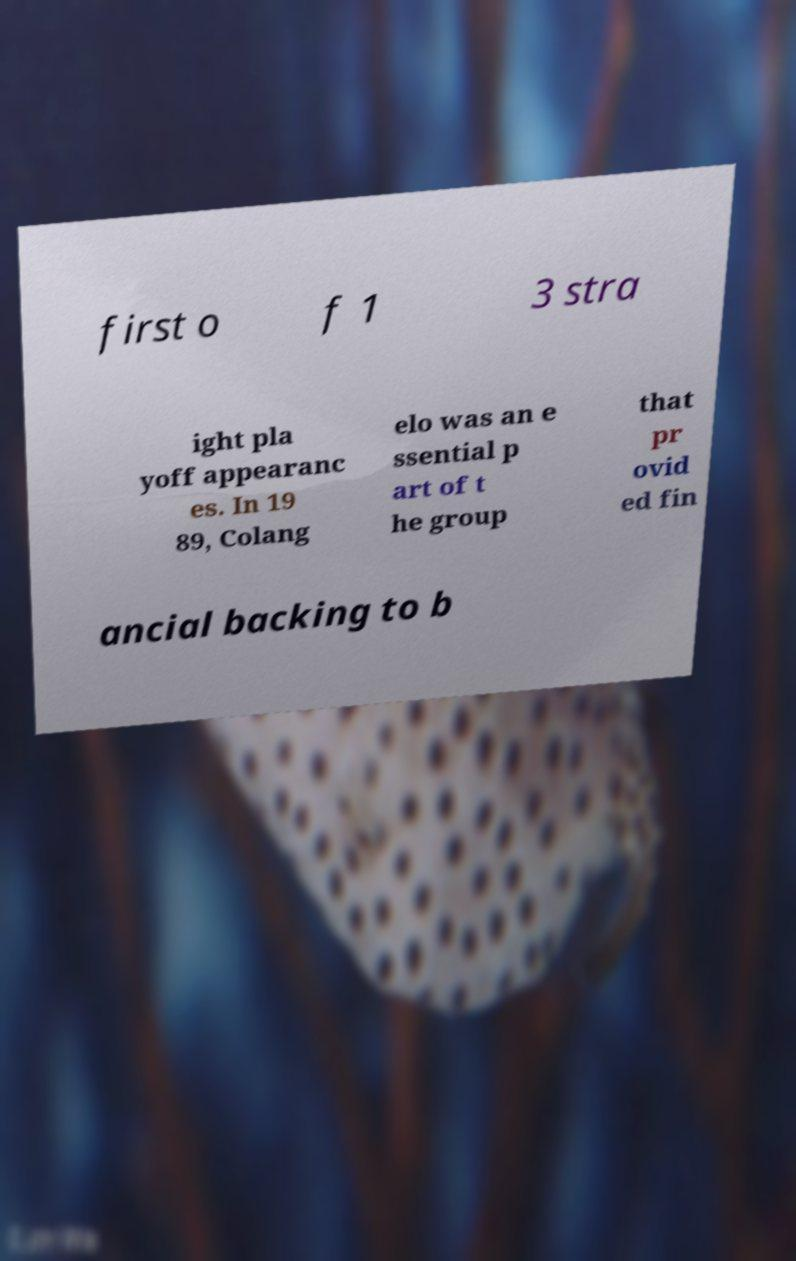Can you read and provide the text displayed in the image?This photo seems to have some interesting text. Can you extract and type it out for me? first o f 1 3 stra ight pla yoff appearanc es. In 19 89, Colang elo was an e ssential p art of t he group that pr ovid ed fin ancial backing to b 